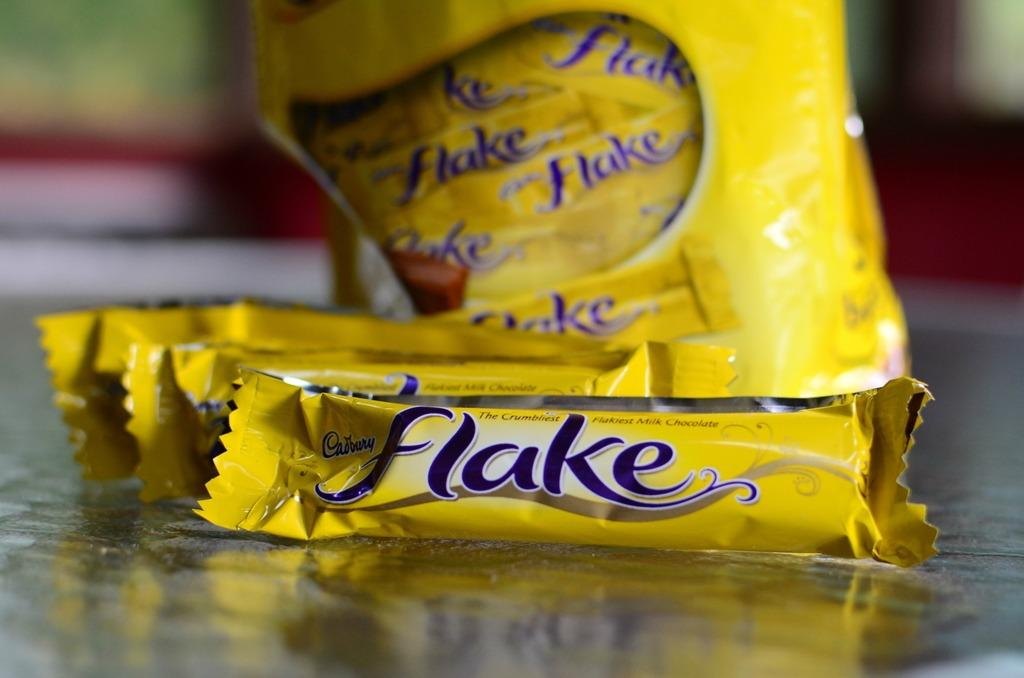What is on the floor in the image? There are chocolates on the floor in the image. What sound does the comb make when used on the chocolates in the image? There is no comb present in the image, and therefore no such sound can be heard. 